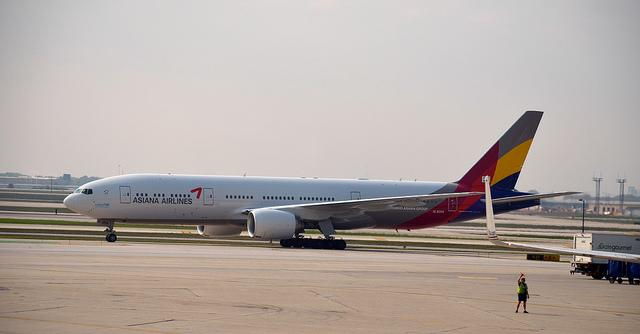Why is the man holding up an orange object?

Choices:
A) direct traffic
B) to eat
C) to fight
D) to dance direct traffic 